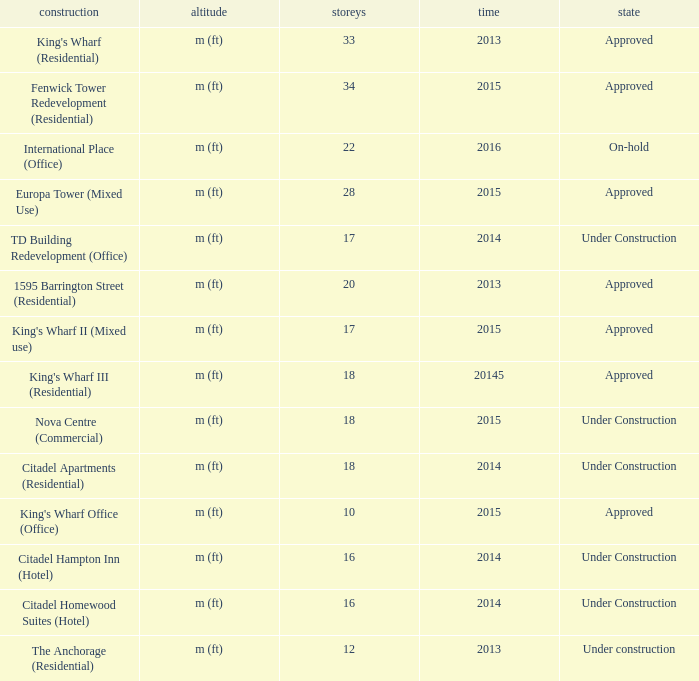What is the status of the building with more than 28 floor and a year of 2013? Approved. 